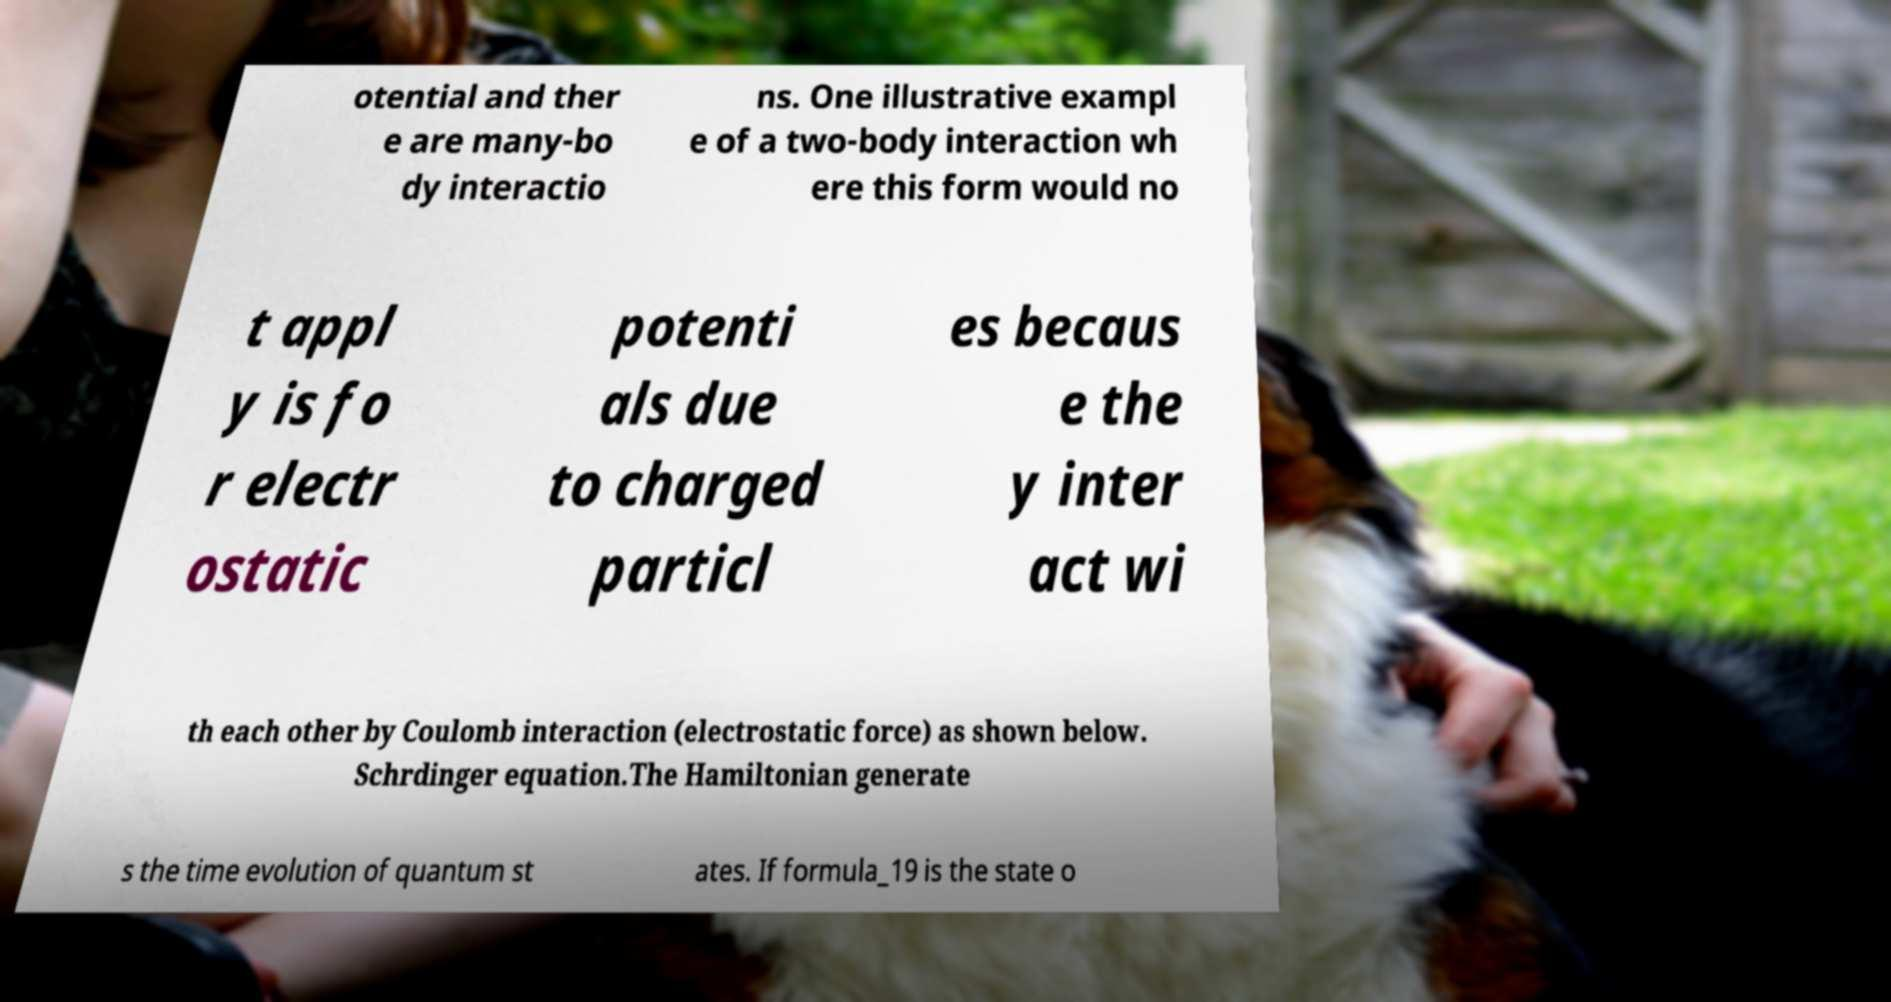For documentation purposes, I need the text within this image transcribed. Could you provide that? otential and ther e are many-bo dy interactio ns. One illustrative exampl e of a two-body interaction wh ere this form would no t appl y is fo r electr ostatic potenti als due to charged particl es becaus e the y inter act wi th each other by Coulomb interaction (electrostatic force) as shown below. Schrdinger equation.The Hamiltonian generate s the time evolution of quantum st ates. If formula_19 is the state o 